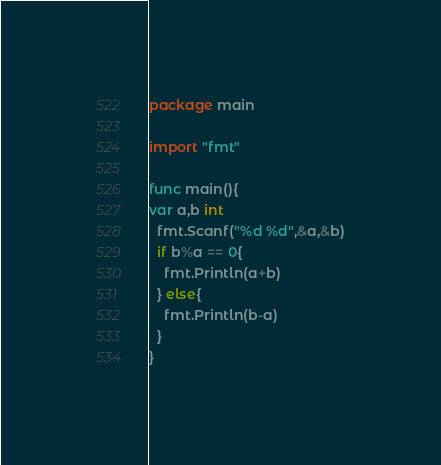<code> <loc_0><loc_0><loc_500><loc_500><_Go_>package main

import "fmt"

func main(){
var a,b int
  fmt.Scanf("%d %d",&a,&b)
  if b%a == 0{
    fmt.Println(a+b)
  } else{
    fmt.Println(b-a)
  }
}</code> 